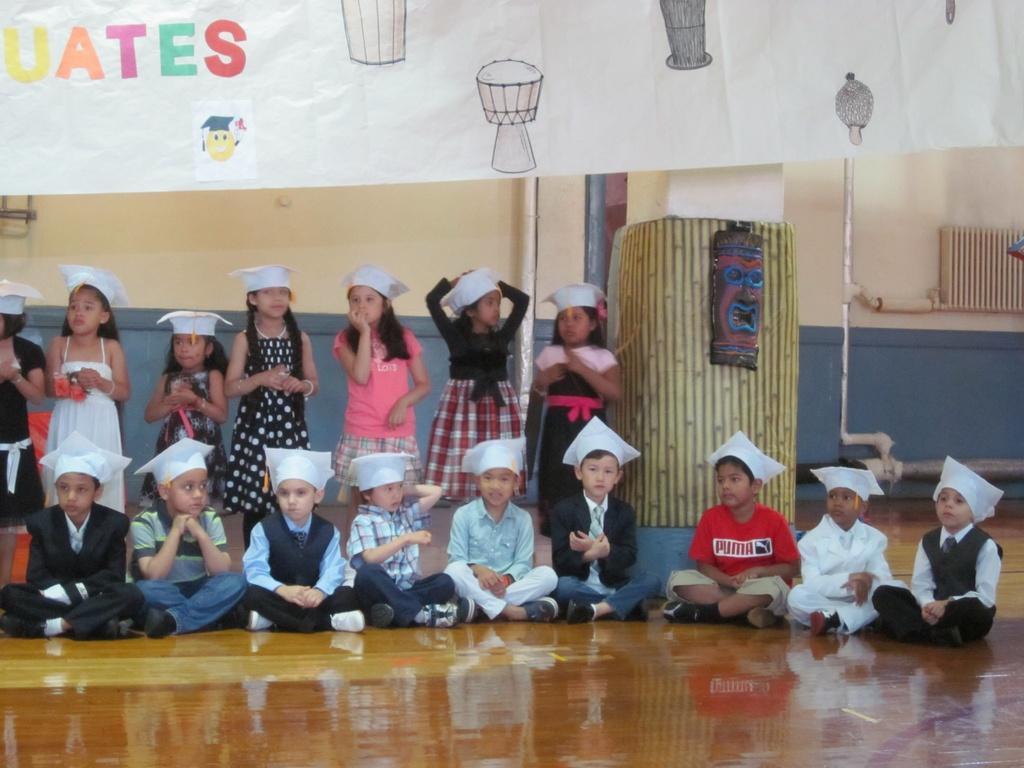Describe this image in one or two sentences. In this picture we can see a few girls standing and some boys sitting on the floor. We can see some text and a few figures on the banner. There are pipes, some objects and a wall is visible in the background. 